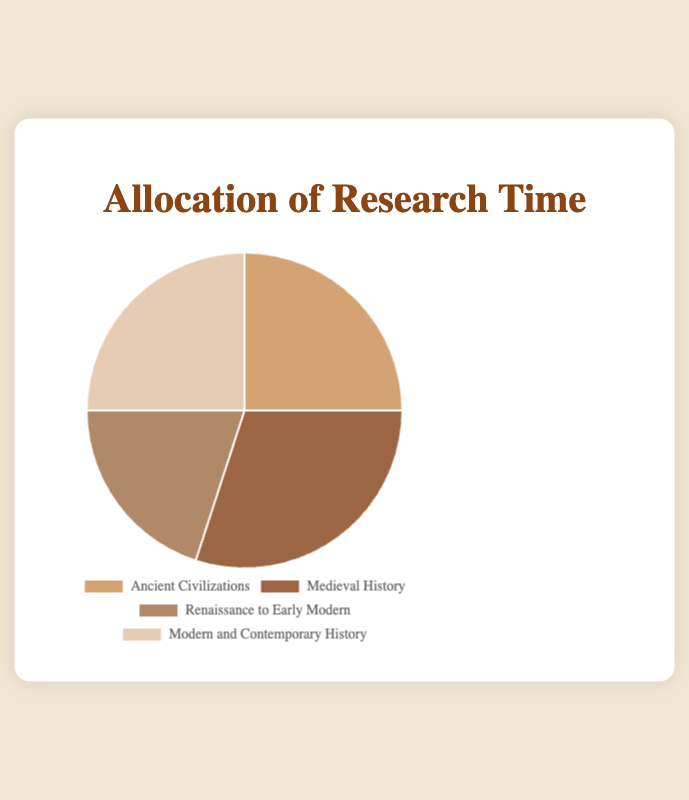What percentage of research time is allocated to Ancient Civilizations? The pie chart shows that Ancient Civilizations occupy one segment of the pie with a label indicating a percentage. By looking at this segment, we see the value is 25%.
Answer: 25% How do Medieval History and Renaissance to Early Modern periods compare in terms of allocated research time? The pie chart shows that Medieval History has a segment labeled 30%, whereas the Renaissance to Early Modern period has a segment labeled 20%. Thus, Medieval History has a larger allocation of research time.
Answer: Medieval History has a larger allocation Which historical period receives the least amount of research time? By examining the pie chart, we identify that the segment representing the Renaissance to Early Modern period has the smallest percentage value, which is 20%.
Answer: Renaissance to Early Modern Which two periods together account for half of the allocated research time? By considering percentages from the chart, adding the percentages of Ancient Civilizations (25%) and Modern and Contemporary History (25%) gives a total of 50%.
Answer: Ancient Civilizations and Modern and Contemporary History What is the difference in research time allocation between the period with the highest percentage and the period with the lowest percentage? Adding up the individual percentages from the pie chart: Medieval History (30%) - Renaissance to Early Modern (20%) = 10%.
Answer: 10% What are the colors used for the Ancient Civilizations and Medieval History segments in the pie chart? Direct observation of the pie chart reveals that the Ancient Civilizations segment is represented by a brown shade and the Medieval History segment appears in a darker brown hue.
Answer: Ancient Civilizations: brown, Medieval History: dark brown If you combine the research time allocated to Medieval History and Modern and Contemporary History, what percentage of the total do they represent? Adding the percentages from the chart: Medieval History (30%) + Modern and Contemporary History (25%) gives a total of 55%.
Answer: 55% How much more time is allocated to Medieval History compared to Ancient Civilizations? Evaluating the percentages from the pie chart: Medieval History (30%) - Ancient Civilizations (25%) equals a 5% difference.
Answer: 5% What is the average percentage of research time spent across all periods? Summing up the percentages from the chart: 25% (Ancient Civilizations) + 30% (Medieval History) + 20% (Renaissance to Early Modern) + 25% (Modern and Contemporary History) gives a total of 100%. Dividing by the four periods, the average is 100% / 4 = 25%.
Answer: 25% Which segment in the pie chart appears largest in size, and which appears smallest? Visually assessing the segments, the pie chart shows that the Medieval History segment, labeled as 30%, appears largest, while the Renaissance to Early Modern segment, labeled as 20%, appears smallest.
Answer: Largest: Medieval History, Smallest: Renaissance to Early Modern 